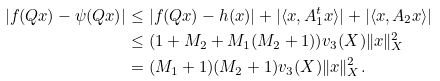Convert formula to latex. <formula><loc_0><loc_0><loc_500><loc_500>| f ( Q x ) - \psi ( Q x ) | & \leq | f ( Q x ) - h ( x ) | + | \langle x , A _ { 1 } ^ { t } x \rangle | + | \langle x , A _ { 2 } x \rangle | \quad \\ & \leq ( 1 + M _ { 2 } + M _ { 1 } ( M _ { 2 } + 1 ) ) v _ { 3 } ( X ) \| x \| _ { X } ^ { 2 } \\ & = ( M _ { 1 } + 1 ) ( M _ { 2 } + 1 ) v _ { 3 } ( X ) \| x \| _ { X } ^ { 2 } .</formula> 